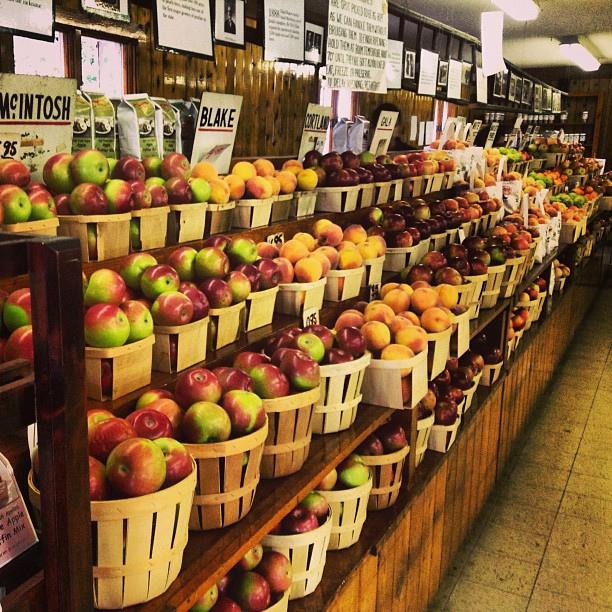What does the sign furthest left say?
Quick response, please. Mcintosh. Is this Apple Castle in New Wilmington, PA?
Give a very brief answer. Yes. Do you see fruit other than apples?
Keep it brief. Yes. Would any of the produce in the photo make a good pie filling?
Concise answer only. Yes. 